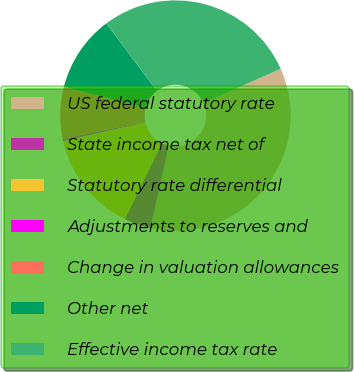Convert chart to OTSL. <chart><loc_0><loc_0><loc_500><loc_500><pie_chart><fcel>US federal statutory rate<fcel>State income tax net of<fcel>Statutory rate differential<fcel>Adjustments to reserves and<fcel>Change in valuation allowances<fcel>Other net<fcel>Effective income tax rate<nl><fcel>35.11%<fcel>3.78%<fcel>14.22%<fcel>0.3%<fcel>7.26%<fcel>10.74%<fcel>28.59%<nl></chart> 